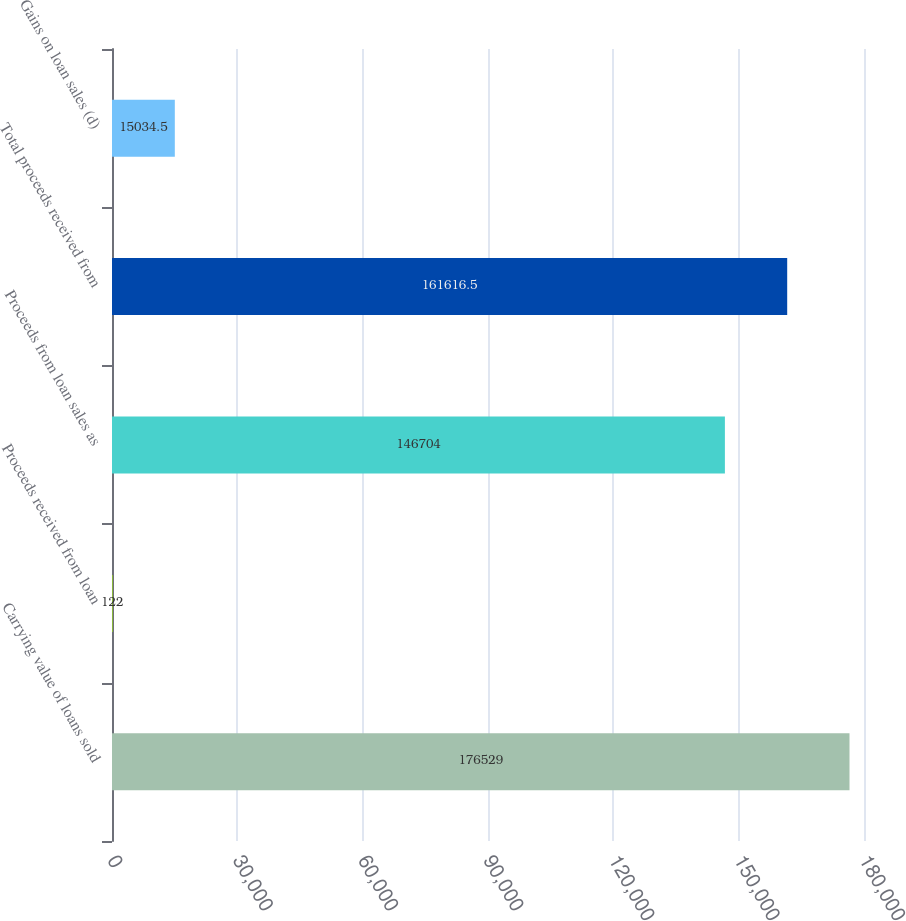<chart> <loc_0><loc_0><loc_500><loc_500><bar_chart><fcel>Carrying value of loans sold<fcel>Proceeds received from loan<fcel>Proceeds from loan sales as<fcel>Total proceeds received from<fcel>Gains on loan sales (d)<nl><fcel>176529<fcel>122<fcel>146704<fcel>161616<fcel>15034.5<nl></chart> 